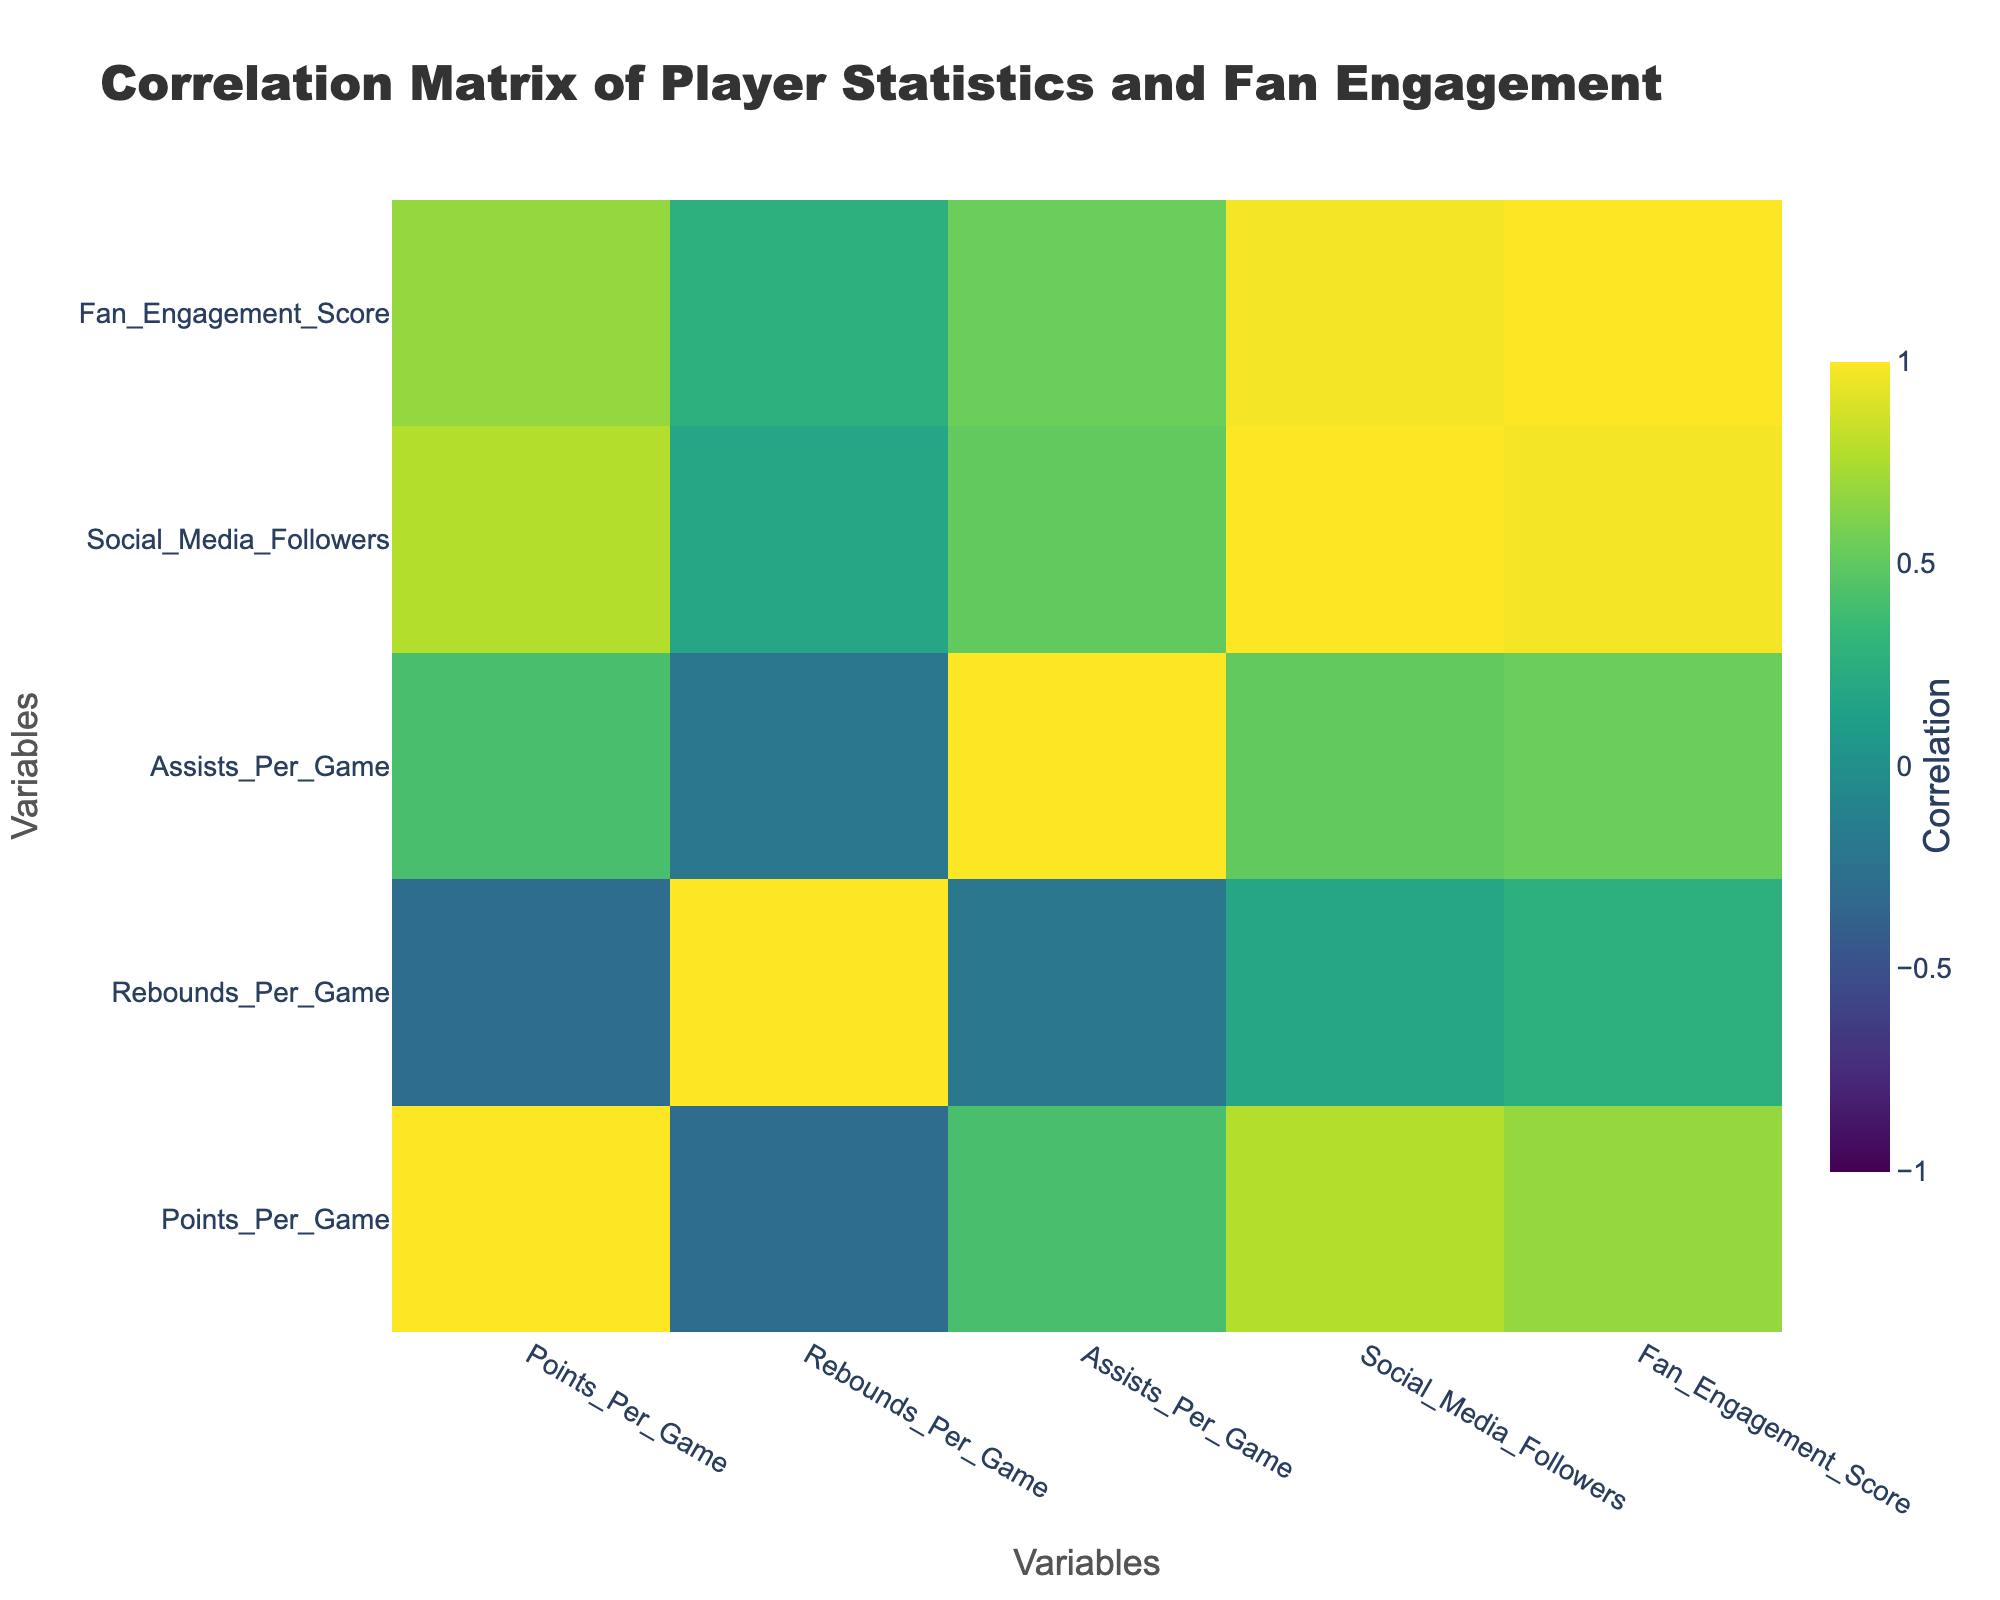What is the correlation between points per game and fan engagement score? Looking at the correlation matrix, the correlation coefficient for points per game and fan engagement score is 0.46. This indicates a moderate positive correlation, meaning as points per game increase, the fan engagement score tends to increase as well.
Answer: 0.46 Which player has the highest fan engagement score? By reviewing the fan engagement scores in the table, the player with the highest score is Stephen Curry with a score of 90.
Answer: Stephen Curry Is there a positive correlation between rebounds per game and social media followers? Inspecting the correlation matrix, the correlation between rebounds per game and social media followers is 0.21, indicating a weak positive correlation. This suggests that higher rebounds per game are slightly associated with more social media followers.
Answer: Yes Calculate the average points per game of all players listed. Adding up all the points per game: (25.0 + 29.5 + 26.4 + 27.6 + 27.7 + 24.8 + 24.6 + 28.8 + 23.6 + 22.5) gives a total of 258.5. Dividing by the 10 players yields an average of 25.85.
Answer: 25.85 Is Kevin Durant's fan engagement score higher than Luka Dončić's? Reviewing the fan engagement scores, Kevin Durant has a score of 80 while Luka Dončić has a score of 87. Thus, Kevin Durant's score is not higher than Luka Dončić's.
Answer: No What is the correlation between assists per game and points per game? The correlation coefficient for assists per game and points per game is 0.62, which indicates a strong positive correlation. This suggests that players who assist more tend to score more points per game.
Answer: 0.62 Which player has the lowest rebounds per game? Upon examining the rebounds per game column, Zion Williamson has the lowest value with 6.3 rebounds per game.
Answer: Zion Williamson Calculate the difference in social media followers between the player with the most followers and the player with the least followers. The player with the most followers is Stephen Curry with 13,000,000, while the player with the least followers is Zion Williamson with 5,000,000. The difference is 13,000,000 - 5,000,000 = 8,000,000.
Answer: 8,000,000 